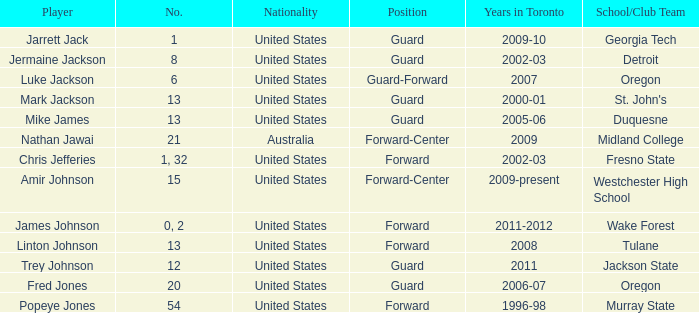What is the overall count of positions on the toronto team in 2006-07? 1.0. 